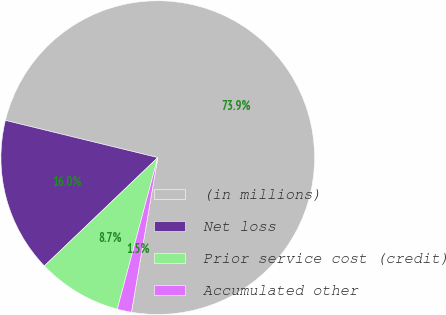<chart> <loc_0><loc_0><loc_500><loc_500><pie_chart><fcel>(in millions)<fcel>Net loss<fcel>Prior service cost (credit)<fcel>Accumulated other<nl><fcel>73.87%<fcel>15.95%<fcel>8.71%<fcel>1.47%<nl></chart> 